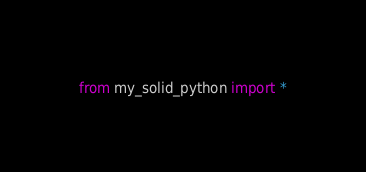<code> <loc_0><loc_0><loc_500><loc_500><_Python_>from my_solid_python import *
</code> 